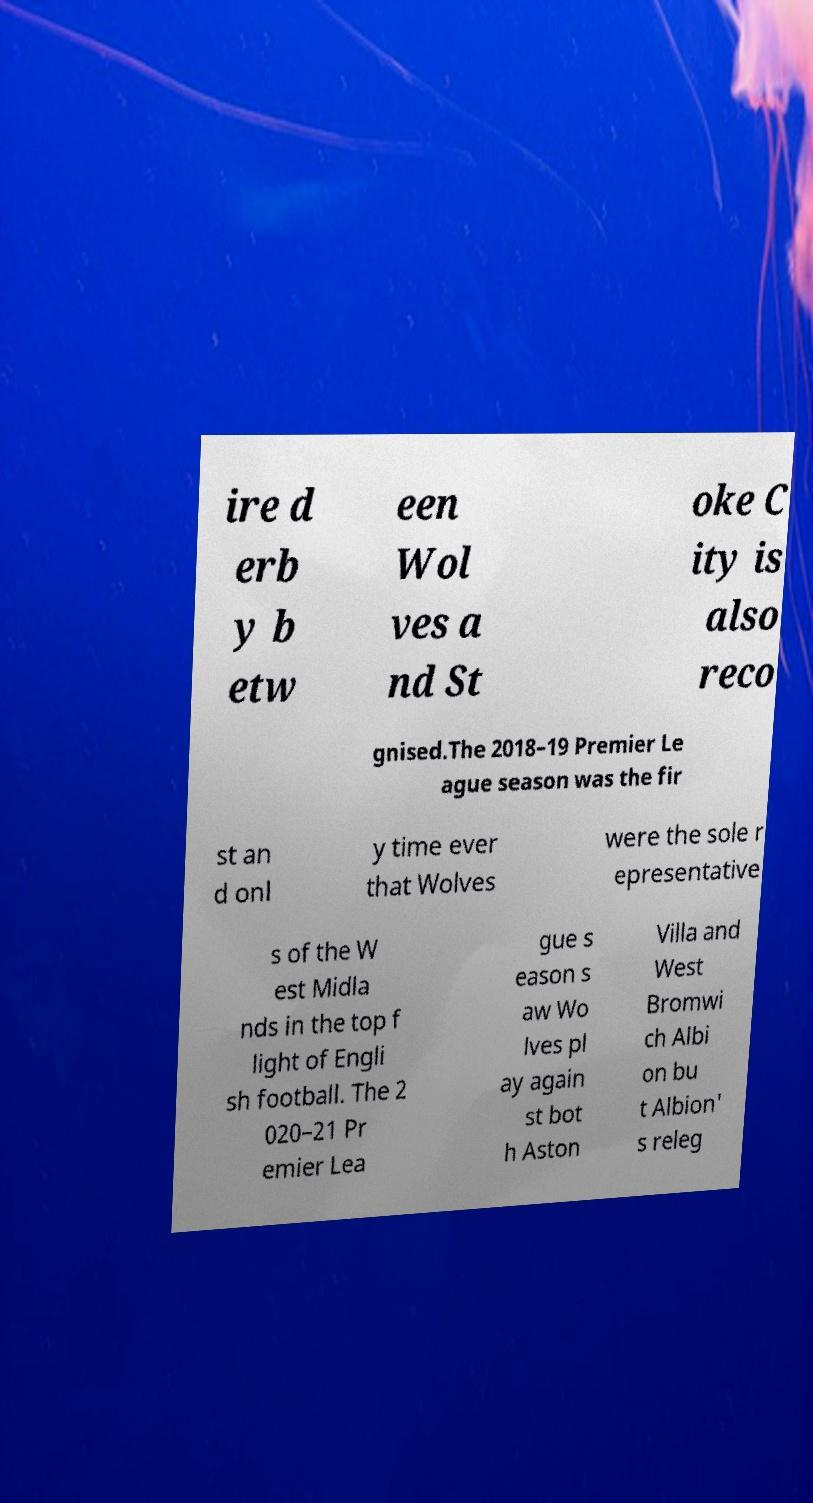Please read and relay the text visible in this image. What does it say? ire d erb y b etw een Wol ves a nd St oke C ity is also reco gnised.The 2018–19 Premier Le ague season was the fir st an d onl y time ever that Wolves were the sole r epresentative s of the W est Midla nds in the top f light of Engli sh football. The 2 020–21 Pr emier Lea gue s eason s aw Wo lves pl ay again st bot h Aston Villa and West Bromwi ch Albi on bu t Albion' s releg 